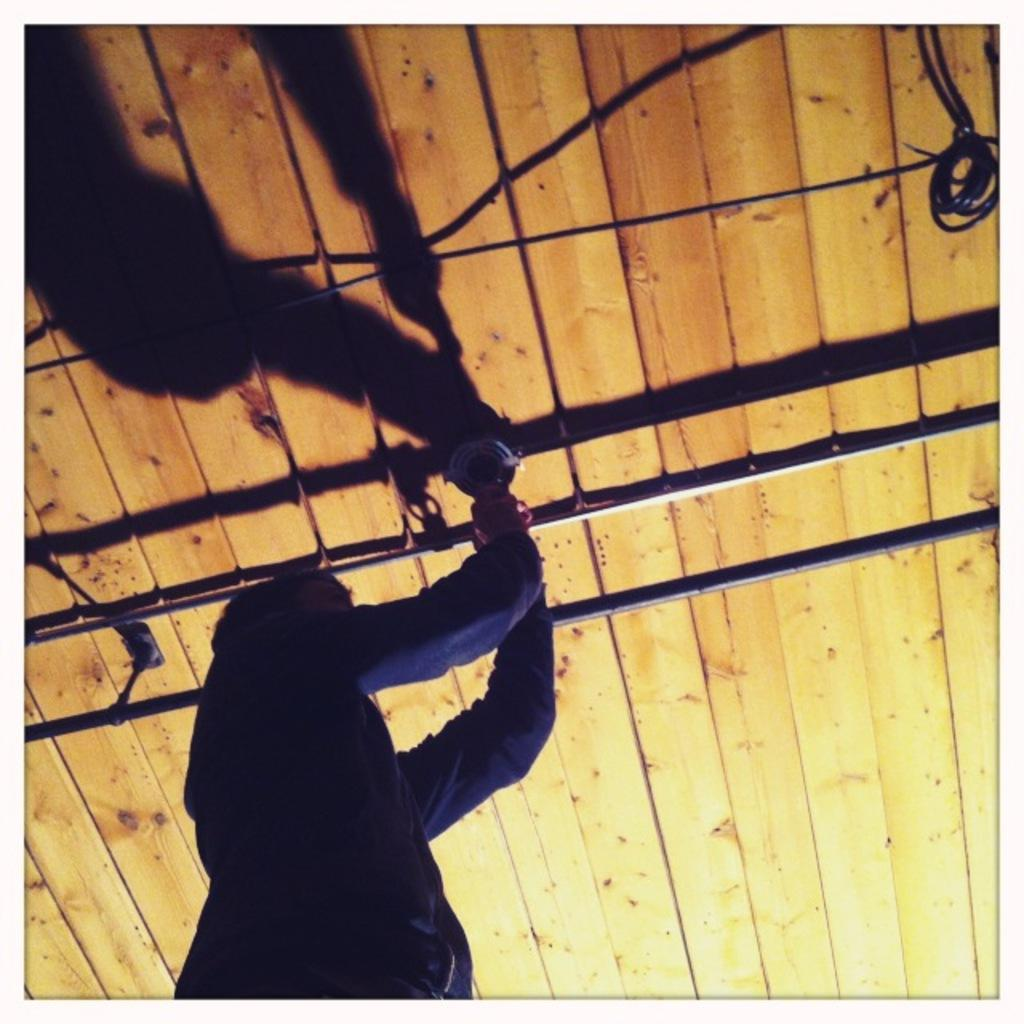What can be seen in the image? There is a person in the image. Can you describe the person's appearance? The person is wearing clothes. What is the person holding in their hand? The person is holding an object in their hand. What other objects or structures can be seen in the image? There are pipes, a cable wire, and wooden sheets in the image. How does the wind affect the wooden sheets in the image? There is no wind present in the image, so its effect on the wooden sheets cannot be determined. 